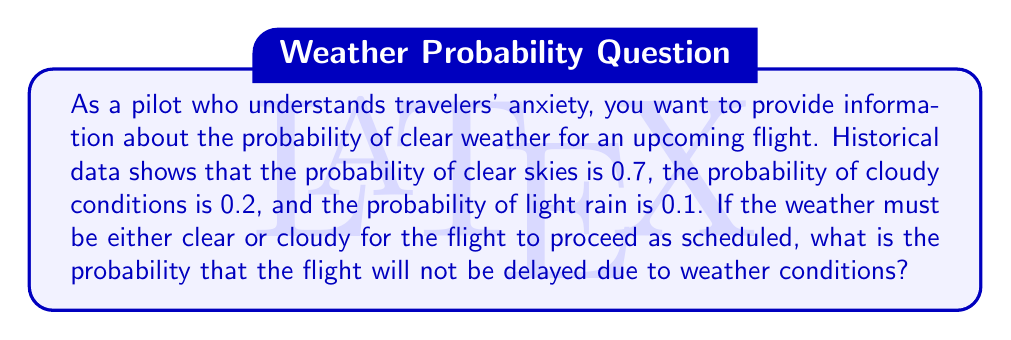Give your solution to this math problem. To solve this problem, we'll use the concept of probability addition from information theory. Let's break it down step by step:

1) Let's define our events:
   A: Clear skies
   B: Cloudy conditions
   C: Light rain

2) Given probabilities:
   P(A) = 0.7
   P(B) = 0.2
   P(C) = 0.1

3) The flight will proceed as scheduled if the weather is either clear or cloudy. This means we need to find P(A or B).

4) In probability theory, for mutually exclusive events (which these weather conditions are), the probability of either event occurring is the sum of their individual probabilities. This is expressed as:

   $$P(A \text{ or } B) = P(A) + P(B)$$

5) Substituting our known values:

   $$P(A \text{ or } B) = 0.7 + 0.2 = 0.9$$

6) We can verify this result by noting that the sum of all probabilities should equal 1:

   $$P(A) + P(B) + P(C) = 0.7 + 0.2 + 0.1 = 1$$

7) Therefore, the probability that the flight will not be delayed due to weather conditions is 0.9 or 90%.

This high probability can be communicated to passengers to help ease their anxiety about potential weather-related delays.
Answer: The probability that the flight will not be delayed due to weather conditions is $0.9$ or $90\%$. 